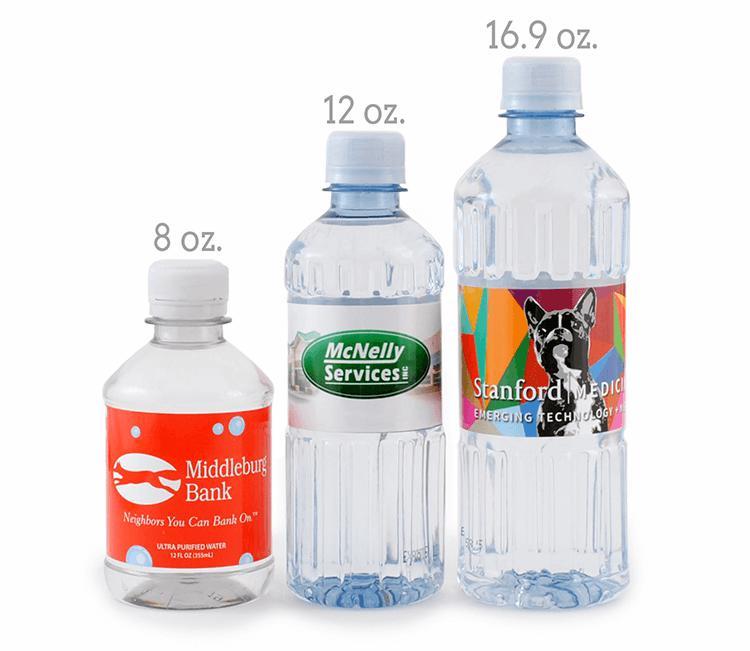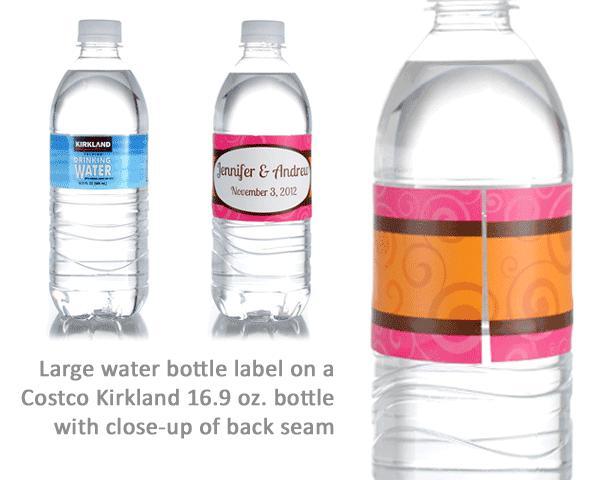The first image is the image on the left, the second image is the image on the right. Examine the images to the left and right. Is the description "The bottle on the right has a blue label." accurate? Answer yes or no. No. 